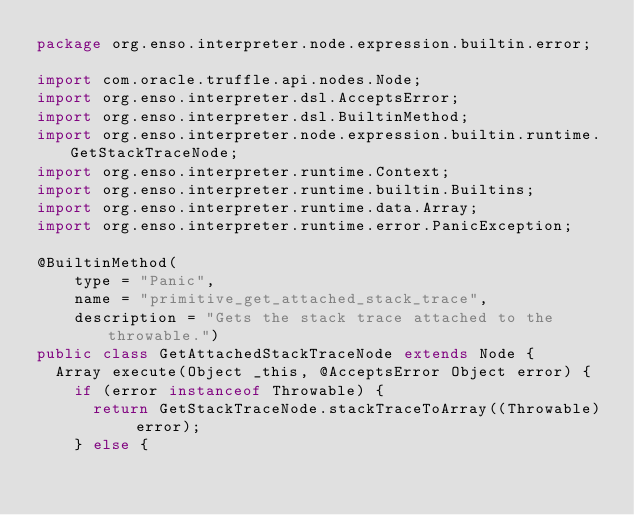<code> <loc_0><loc_0><loc_500><loc_500><_Java_>package org.enso.interpreter.node.expression.builtin.error;

import com.oracle.truffle.api.nodes.Node;
import org.enso.interpreter.dsl.AcceptsError;
import org.enso.interpreter.dsl.BuiltinMethod;
import org.enso.interpreter.node.expression.builtin.runtime.GetStackTraceNode;
import org.enso.interpreter.runtime.Context;
import org.enso.interpreter.runtime.builtin.Builtins;
import org.enso.interpreter.runtime.data.Array;
import org.enso.interpreter.runtime.error.PanicException;

@BuiltinMethod(
    type = "Panic",
    name = "primitive_get_attached_stack_trace",
    description = "Gets the stack trace attached to the throwable.")
public class GetAttachedStackTraceNode extends Node {
  Array execute(Object _this, @AcceptsError Object error) {
    if (error instanceof Throwable) {
      return GetStackTraceNode.stackTraceToArray((Throwable) error);
    } else {</code> 